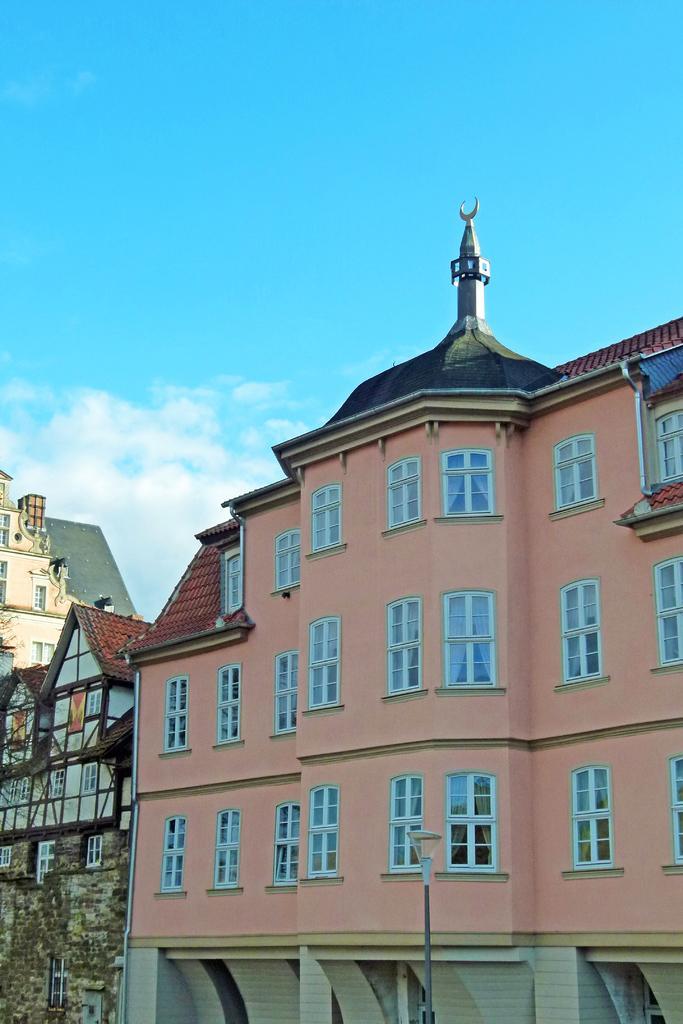In one or two sentences, can you explain what this image depicts? In this image we can see the buildings, light pole and also the sky with the clouds in the background. 